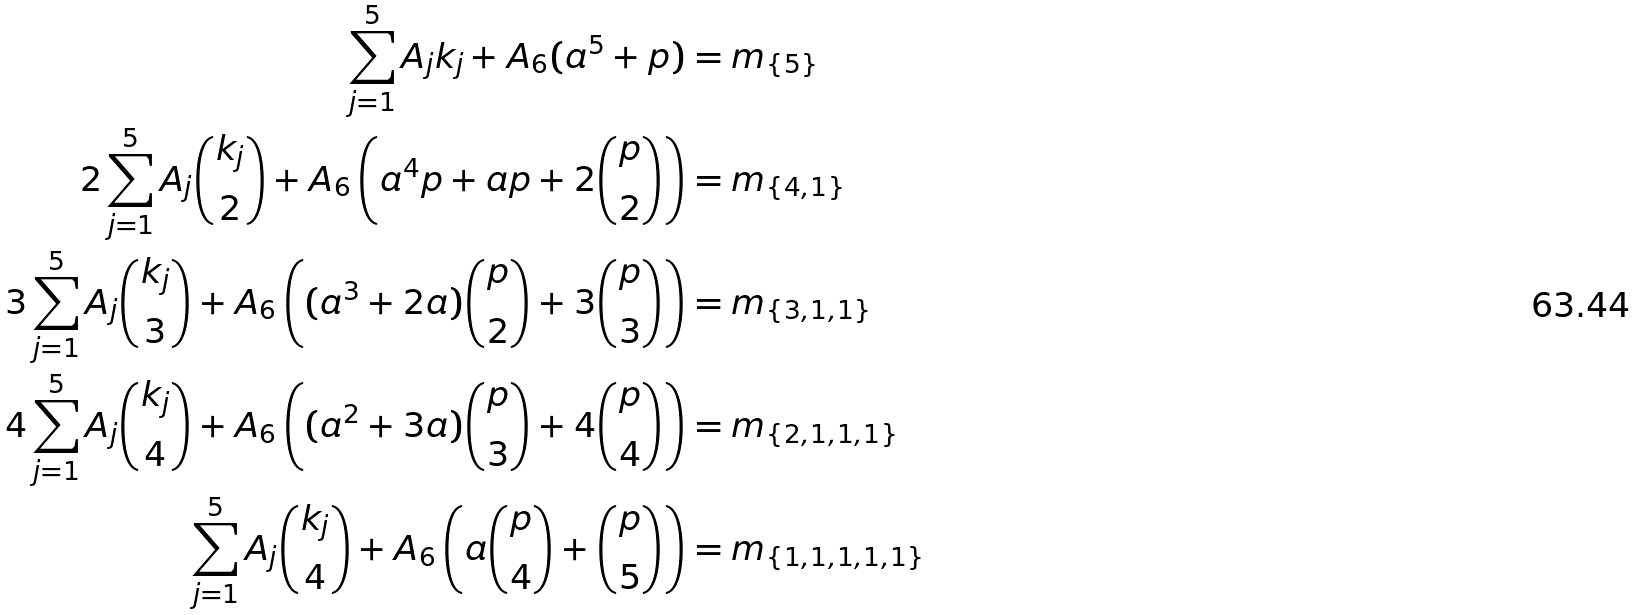<formula> <loc_0><loc_0><loc_500><loc_500>\sum _ { j = 1 } ^ { 5 } A _ { j } k _ { j } + A _ { 6 } ( a ^ { 5 } + p ) & = m _ { \{ 5 \} } \\ 2 \sum _ { j = 1 } ^ { 5 } A _ { j } \binom { k _ { j } } { 2 } + A _ { 6 } \left ( a ^ { 4 } p + a p + 2 \binom { p } { 2 } \right ) & = m _ { \{ 4 , 1 \} } \\ 3 \sum _ { j = 1 } ^ { 5 } A _ { j } \binom { k _ { j } } { 3 } + A _ { 6 } \left ( ( a ^ { 3 } + 2 a ) \binom { p } { 2 } + 3 \binom { p } { 3 } \right ) & = m _ { \{ 3 , 1 , 1 \} } \\ 4 \sum _ { j = 1 } ^ { 5 } A _ { j } \binom { k _ { j } } { 4 } + A _ { 6 } \left ( ( a ^ { 2 } + 3 a ) \binom { p } { 3 } + 4 \binom { p } { 4 } \right ) & = m _ { \{ 2 , 1 , 1 , 1 \} } \\ \sum _ { j = 1 } ^ { 5 } A _ { j } \binom { k _ { j } } { 4 } + A _ { 6 } \left ( a \binom { p } { 4 } + \binom { p } { 5 } \right ) & = m _ { \{ 1 , 1 , 1 , 1 , 1 \} }</formula> 